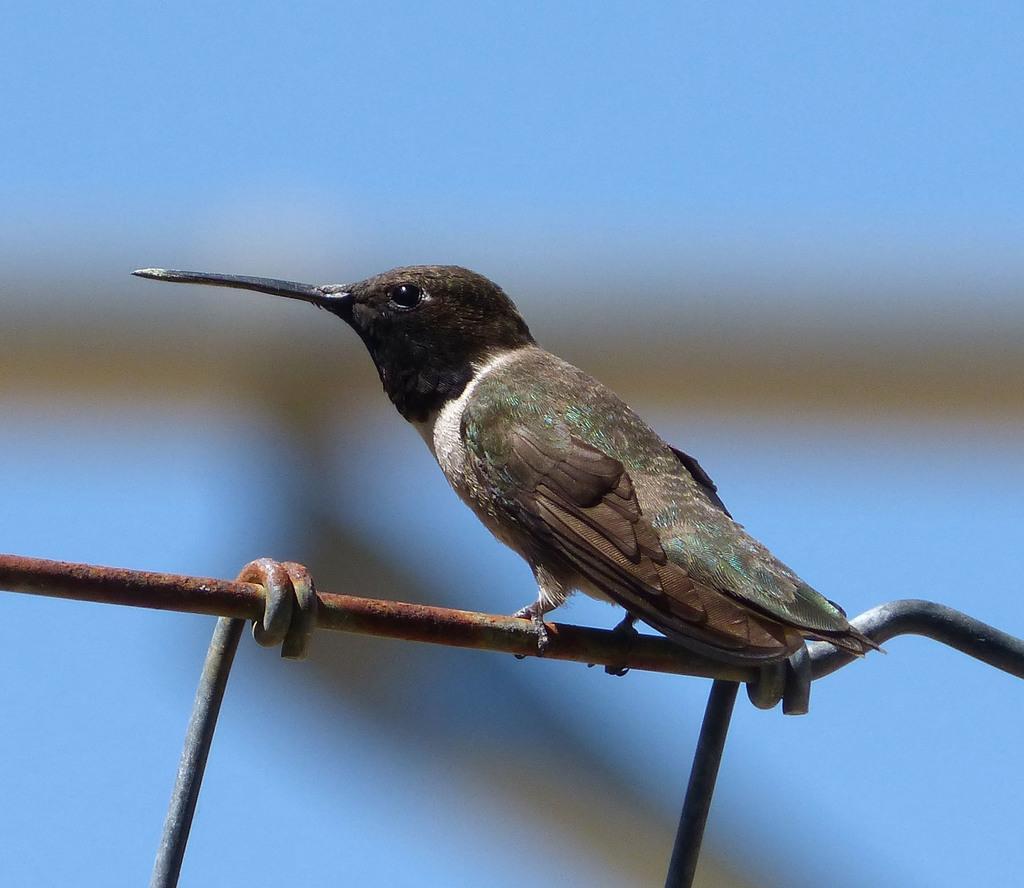In one or two sentences, can you explain what this image depicts? This image consists of a sparrow sitting on a metal road. It is in black color. In the background, the image is totally blurred. 